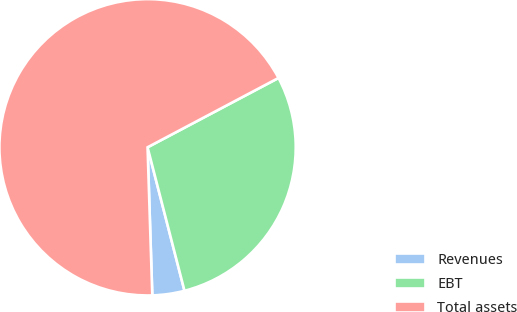Convert chart to OTSL. <chart><loc_0><loc_0><loc_500><loc_500><pie_chart><fcel>Revenues<fcel>EBT<fcel>Total assets<nl><fcel>3.5%<fcel>28.74%<fcel>67.76%<nl></chart> 